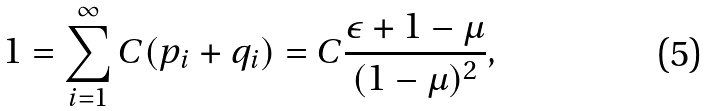<formula> <loc_0><loc_0><loc_500><loc_500>1 = \sum _ { i = 1 } ^ { \infty } C ( p _ { i } + q _ { i } ) = C \frac { \epsilon + 1 - \mu } { ( 1 - \mu ) ^ { 2 } } ,</formula> 